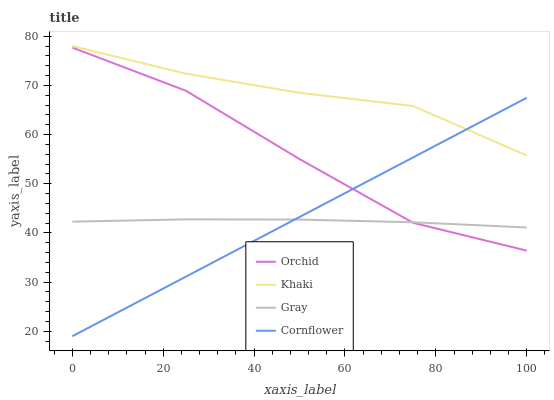Does Gray have the minimum area under the curve?
Answer yes or no. Yes. Does Khaki have the maximum area under the curve?
Answer yes or no. Yes. Does Cornflower have the minimum area under the curve?
Answer yes or no. No. Does Cornflower have the maximum area under the curve?
Answer yes or no. No. Is Cornflower the smoothest?
Answer yes or no. Yes. Is Orchid the roughest?
Answer yes or no. Yes. Is Khaki the smoothest?
Answer yes or no. No. Is Khaki the roughest?
Answer yes or no. No. Does Cornflower have the lowest value?
Answer yes or no. Yes. Does Khaki have the lowest value?
Answer yes or no. No. Does Khaki have the highest value?
Answer yes or no. Yes. Does Cornflower have the highest value?
Answer yes or no. No. Is Gray less than Khaki?
Answer yes or no. Yes. Is Khaki greater than Orchid?
Answer yes or no. Yes. Does Orchid intersect Gray?
Answer yes or no. Yes. Is Orchid less than Gray?
Answer yes or no. No. Is Orchid greater than Gray?
Answer yes or no. No. Does Gray intersect Khaki?
Answer yes or no. No. 